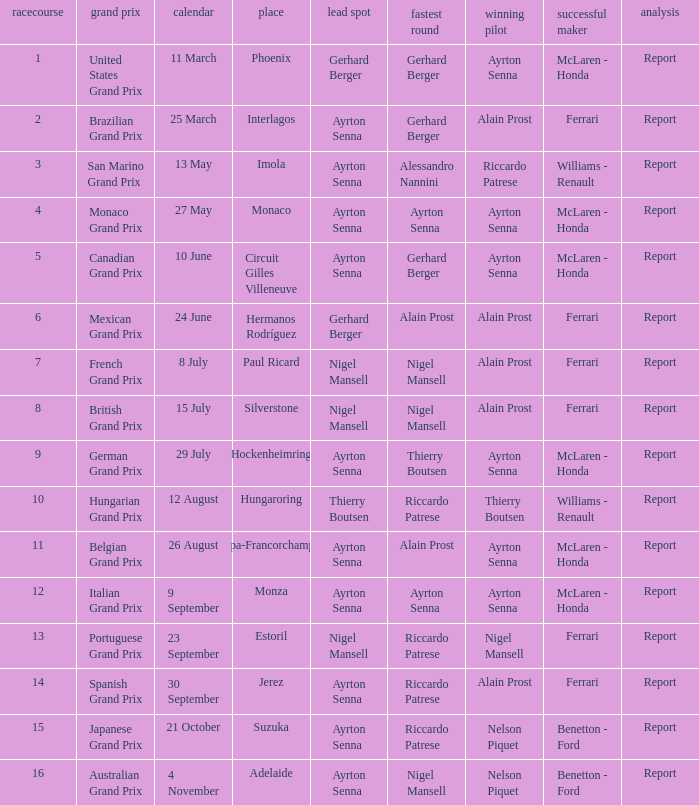What is the date that Ayrton Senna was the drive in Monza? 9 September. Parse the table in full. {'header': ['racecourse', 'grand prix', 'calendar', 'place', 'lead spot', 'fastest round', 'winning pilot', 'successful maker', 'analysis'], 'rows': [['1', 'United States Grand Prix', '11 March', 'Phoenix', 'Gerhard Berger', 'Gerhard Berger', 'Ayrton Senna', 'McLaren - Honda', 'Report'], ['2', 'Brazilian Grand Prix', '25 March', 'Interlagos', 'Ayrton Senna', 'Gerhard Berger', 'Alain Prost', 'Ferrari', 'Report'], ['3', 'San Marino Grand Prix', '13 May', 'Imola', 'Ayrton Senna', 'Alessandro Nannini', 'Riccardo Patrese', 'Williams - Renault', 'Report'], ['4', 'Monaco Grand Prix', '27 May', 'Monaco', 'Ayrton Senna', 'Ayrton Senna', 'Ayrton Senna', 'McLaren - Honda', 'Report'], ['5', 'Canadian Grand Prix', '10 June', 'Circuit Gilles Villeneuve', 'Ayrton Senna', 'Gerhard Berger', 'Ayrton Senna', 'McLaren - Honda', 'Report'], ['6', 'Mexican Grand Prix', '24 June', 'Hermanos Rodríguez', 'Gerhard Berger', 'Alain Prost', 'Alain Prost', 'Ferrari', 'Report'], ['7', 'French Grand Prix', '8 July', 'Paul Ricard', 'Nigel Mansell', 'Nigel Mansell', 'Alain Prost', 'Ferrari', 'Report'], ['8', 'British Grand Prix', '15 July', 'Silverstone', 'Nigel Mansell', 'Nigel Mansell', 'Alain Prost', 'Ferrari', 'Report'], ['9', 'German Grand Prix', '29 July', 'Hockenheimring', 'Ayrton Senna', 'Thierry Boutsen', 'Ayrton Senna', 'McLaren - Honda', 'Report'], ['10', 'Hungarian Grand Prix', '12 August', 'Hungaroring', 'Thierry Boutsen', 'Riccardo Patrese', 'Thierry Boutsen', 'Williams - Renault', 'Report'], ['11', 'Belgian Grand Prix', '26 August', 'Spa-Francorchamps', 'Ayrton Senna', 'Alain Prost', 'Ayrton Senna', 'McLaren - Honda', 'Report'], ['12', 'Italian Grand Prix', '9 September', 'Monza', 'Ayrton Senna', 'Ayrton Senna', 'Ayrton Senna', 'McLaren - Honda', 'Report'], ['13', 'Portuguese Grand Prix', '23 September', 'Estoril', 'Nigel Mansell', 'Riccardo Patrese', 'Nigel Mansell', 'Ferrari', 'Report'], ['14', 'Spanish Grand Prix', '30 September', 'Jerez', 'Ayrton Senna', 'Riccardo Patrese', 'Alain Prost', 'Ferrari', 'Report'], ['15', 'Japanese Grand Prix', '21 October', 'Suzuka', 'Ayrton Senna', 'Riccardo Patrese', 'Nelson Piquet', 'Benetton - Ford', 'Report'], ['16', 'Australian Grand Prix', '4 November', 'Adelaide', 'Ayrton Senna', 'Nigel Mansell', 'Nelson Piquet', 'Benetton - Ford', 'Report']]} 